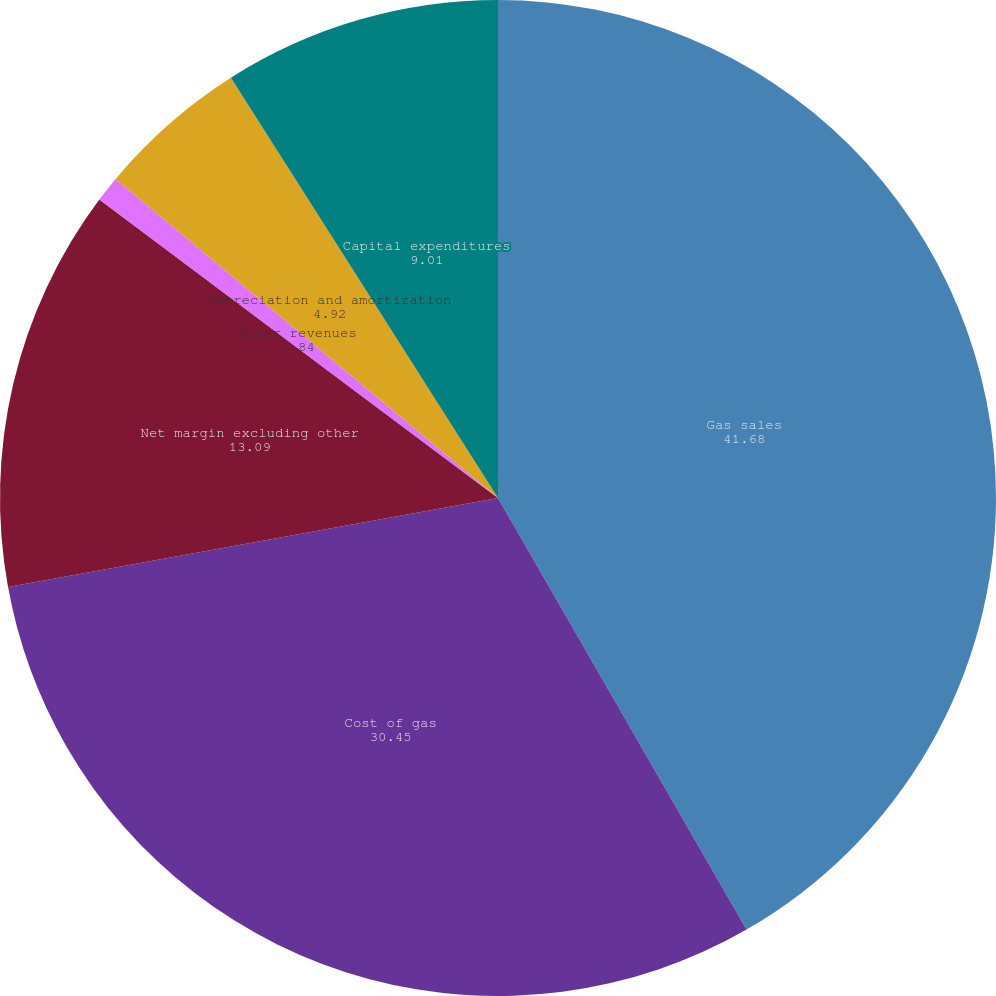<chart> <loc_0><loc_0><loc_500><loc_500><pie_chart><fcel>Gas sales<fcel>Cost of gas<fcel>Net margin excluding other<fcel>Other revenues<fcel>Depreciation and amortization<fcel>Capital expenditures<nl><fcel>41.68%<fcel>30.45%<fcel>13.09%<fcel>0.84%<fcel>4.92%<fcel>9.01%<nl></chart> 